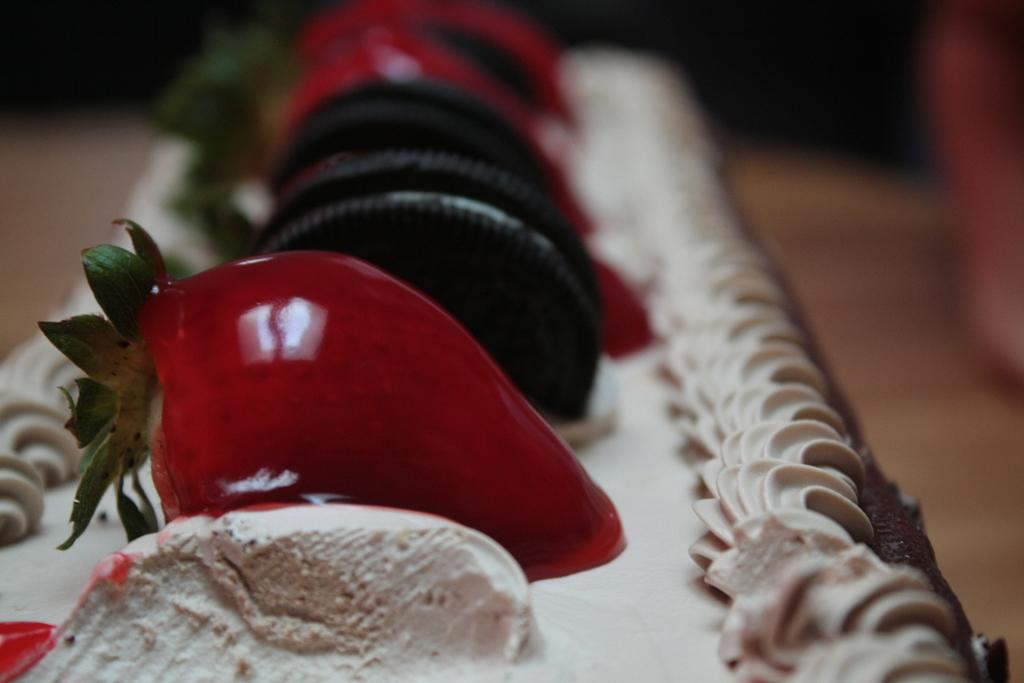What is the main subject of the image? There is a cake in the center of the image. What decorations are on the cake? There are strawberries and biscuits on the cake. What type of lipstick is the cake wearing in the image? There is no lipstick or any indication of a lip in the image; it is a cake with strawberries and biscuits on it. 